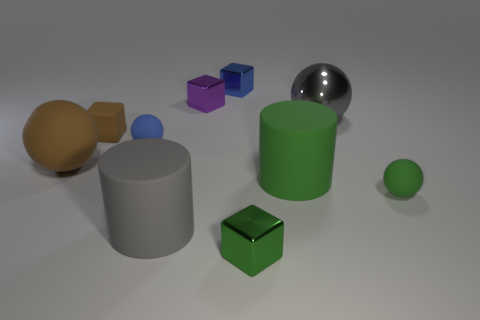Subtract all blocks. How many objects are left? 6 Add 7 purple shiny blocks. How many purple shiny blocks exist? 8 Subtract 1 blue balls. How many objects are left? 9 Subtract all tiny blue cubes. Subtract all gray cylinders. How many objects are left? 8 Add 6 brown rubber spheres. How many brown rubber spheres are left? 7 